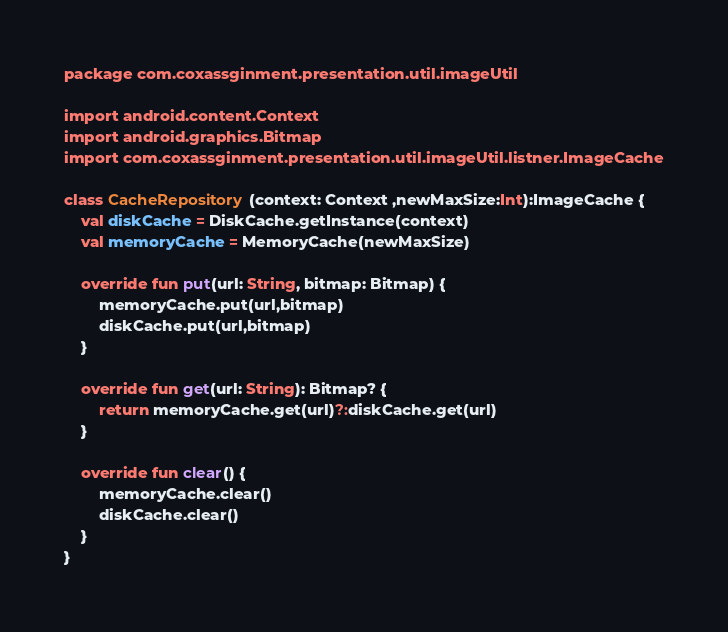<code> <loc_0><loc_0><loc_500><loc_500><_Kotlin_>package com.coxassginment.presentation.util.imageUtil

import android.content.Context
import android.graphics.Bitmap
import com.coxassginment.presentation.util.imageUtil.listner.ImageCache

class CacheRepository (context: Context ,newMaxSize:Int):ImageCache {
    val diskCache = DiskCache.getInstance(context)
    val memoryCache = MemoryCache(newMaxSize)

    override fun put(url: String, bitmap: Bitmap) {
        memoryCache.put(url,bitmap)
        diskCache.put(url,bitmap)
    }

    override fun get(url: String): Bitmap? {
        return memoryCache.get(url)?:diskCache.get(url)
    }

    override fun clear() {
        memoryCache.clear()
        diskCache.clear()
    }
}</code> 